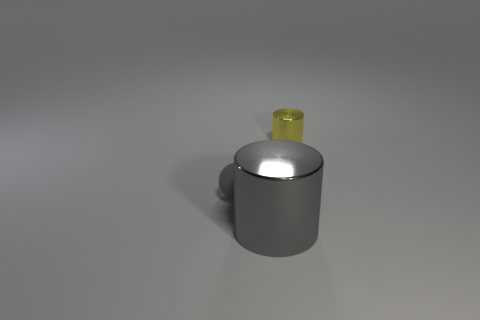Add 1 cyan rubber spheres. How many objects exist? 4 Subtract all balls. How many objects are left? 2 Subtract 1 spheres. How many spheres are left? 0 Subtract all big cylinders. Subtract all large gray metallic objects. How many objects are left? 1 Add 2 big gray metallic cylinders. How many big gray metallic cylinders are left? 3 Add 1 large metallic objects. How many large metallic objects exist? 2 Subtract 0 gray blocks. How many objects are left? 3 Subtract all green cylinders. Subtract all cyan cubes. How many cylinders are left? 2 